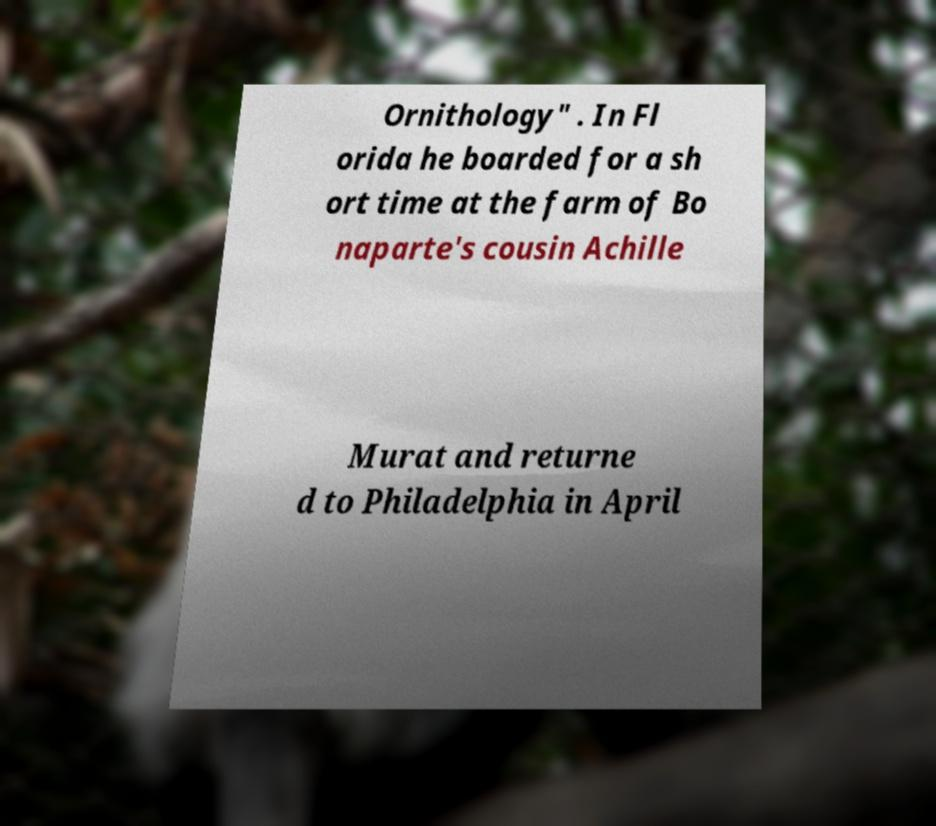Can you accurately transcribe the text from the provided image for me? Ornithology" . In Fl orida he boarded for a sh ort time at the farm of Bo naparte's cousin Achille Murat and returne d to Philadelphia in April 